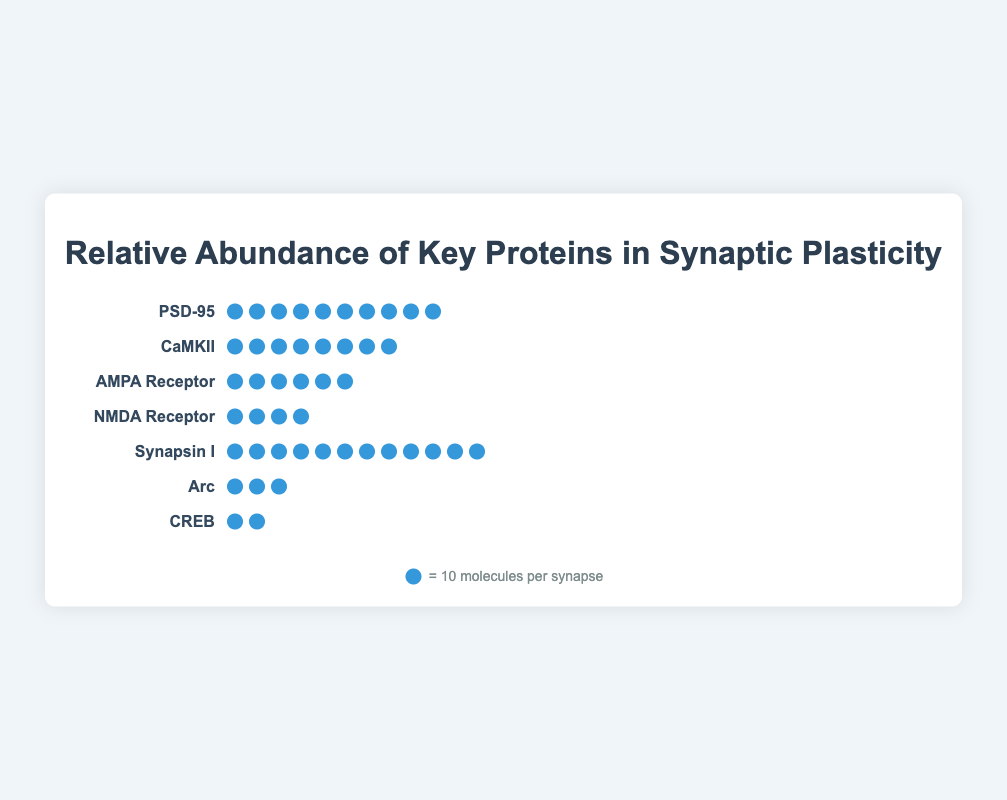What is the most abundant protein shown in the figure? To determine the most abundant protein, look for the protein with the highest number of icons. Synapsin I has the highest count with 120 molecules per synapse, represented by 12 icons.
Answer: Synapsin I Which protein has the lowest relative abundance? Identify the protein with the fewest icons. CREB, with 20 molecules per synapse represented by 2 icons, has the lowest abundance.
Answer: CREB What is the total number of molecules per synapse combined for PSD-95 and CaMKII? Add the abundance of PSD-95 and CaMKII. PSD-95 has 100 molecules per synapse and CaMKII has 80 molecules per synapse, so the total is 100 + 80 = 180.
Answer: 180 How many molecules per synapse does the NMDA Receptor have compared to the AMPA Receptor? To compare, subtract the NMDA Receptor's abundance from the AMPA Receptor's abundance. AMPA Receptor has 60 molecules per synapse, and NMDA Receptor has 40 molecules per synapse, so the difference is 60 - 40 = 20.
Answer: 20 Which proteins have more than 50 molecules per synapse? Look at the icons representing each protein. Synapsin I (120), PSD-95 (100), CaMKII (80), and AMPA Receptor (60) all have more than 50 molecules per synapse.
Answer: Synapsin I, PSD-95, CaMKII, AMPA Receptor Excluding Synapsin I, what is the average abundance of the remaining proteins? Sum the abundance of the other proteins (PSD-95, CaMKII, AMPA Receptor, NMDA Receptor, Arc, CREB) and then divide by the number of these proteins. The total abundance is 100 + 80 + 60 + 40 + 30 + 20 = 330. The number of proteins is 6, so the average is 330 / 6 = 55.
Answer: 55 What is the relationship between the abundance of Arc and CaMKII? Compare the icons representing Arc and CaMKII. Arc has 30 molecules per synapse, while CaMKII has 80 molecules per synapse, so Arc has fewer molecules relative to CaMKII.
Answer: Arc has fewer molecules than CaMKII If each icon represents 10 molecules per synapse, how many icons represent the NMDA Receptor? Divide the NMDA Receptor’s abundance by the number of molecules each icon represents. NMDA Receptor has 40 molecules per synapse, so 40 / 10 = 4 icons.
Answer: 4 Arrange the proteins from the least to most abundant. Order the proteins by the number of icons from least to most. CREB (20), Arc (30), NMDA Receptor (40), AMPA Receptor (60), CaMKII (80), PSD-95 (100), and Synapsin I (120).
Answer: CREB, Arc, NMDA Receptor, AMPA Receptor, CaMKII, PSD-95, Synapsin I 